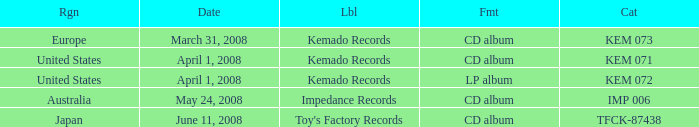Which Region has a Catalog of kem 072? United States. 